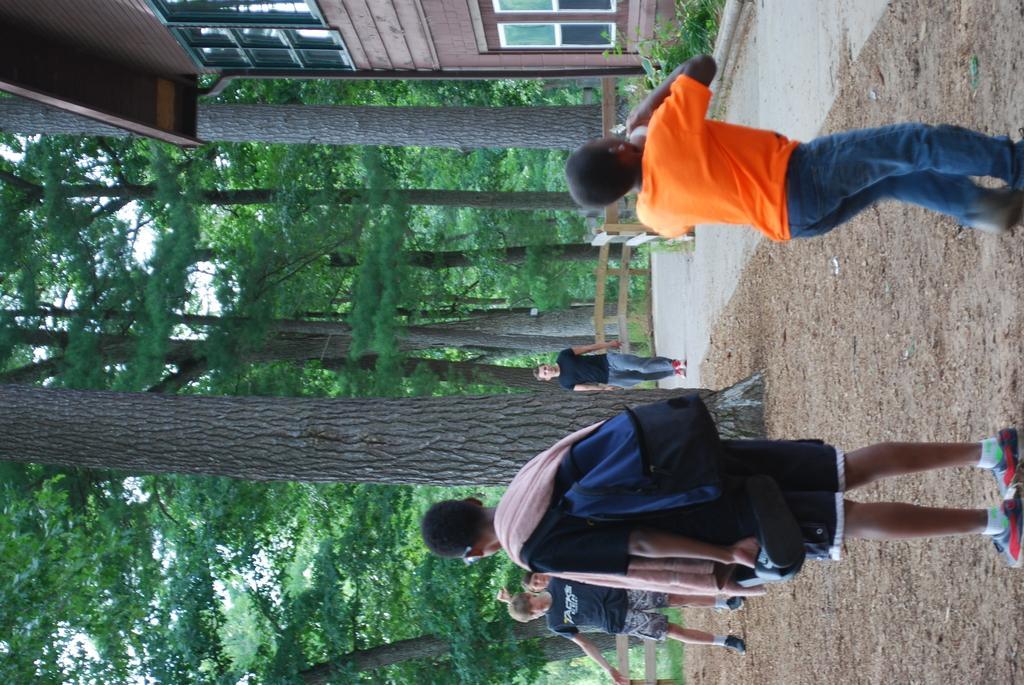In one or two sentences, can you explain what this image depicts? There are few people standing. These are the trees with branches and leaves. This looks like a house with glass windows. I can see small plants. This is the pathway. I think this is the wooden fence. 